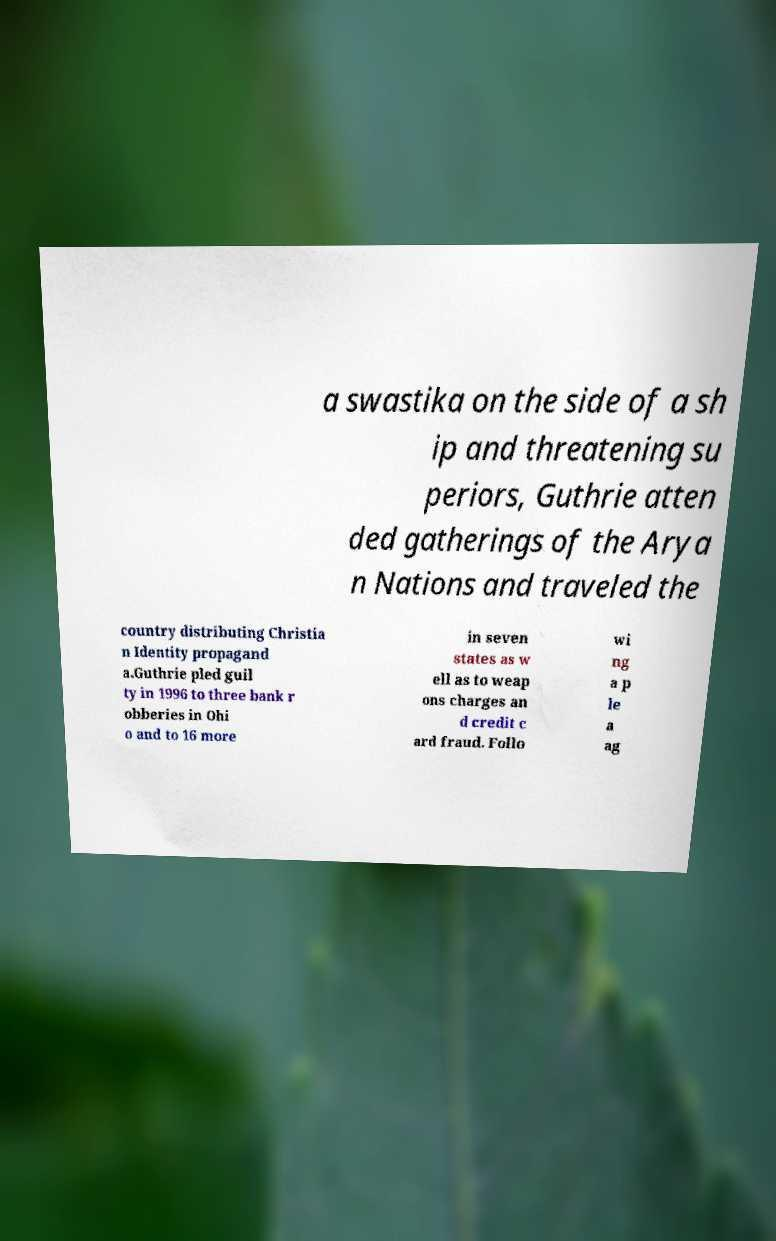Can you accurately transcribe the text from the provided image for me? a swastika on the side of a sh ip and threatening su periors, Guthrie atten ded gatherings of the Arya n Nations and traveled the country distributing Christia n Identity propagand a.Guthrie pled guil ty in 1996 to three bank r obberies in Ohi o and to 16 more in seven states as w ell as to weap ons charges an d credit c ard fraud. Follo wi ng a p le a ag 